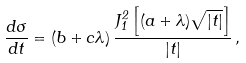Convert formula to latex. <formula><loc_0><loc_0><loc_500><loc_500>\frac { d \sigma } { d t } = ( b + c \lambda ) \, \frac { J _ { 1 } ^ { 2 } \left [ ( a + \lambda ) \sqrt { | t | } \right ] } { | t | } \, ,</formula> 